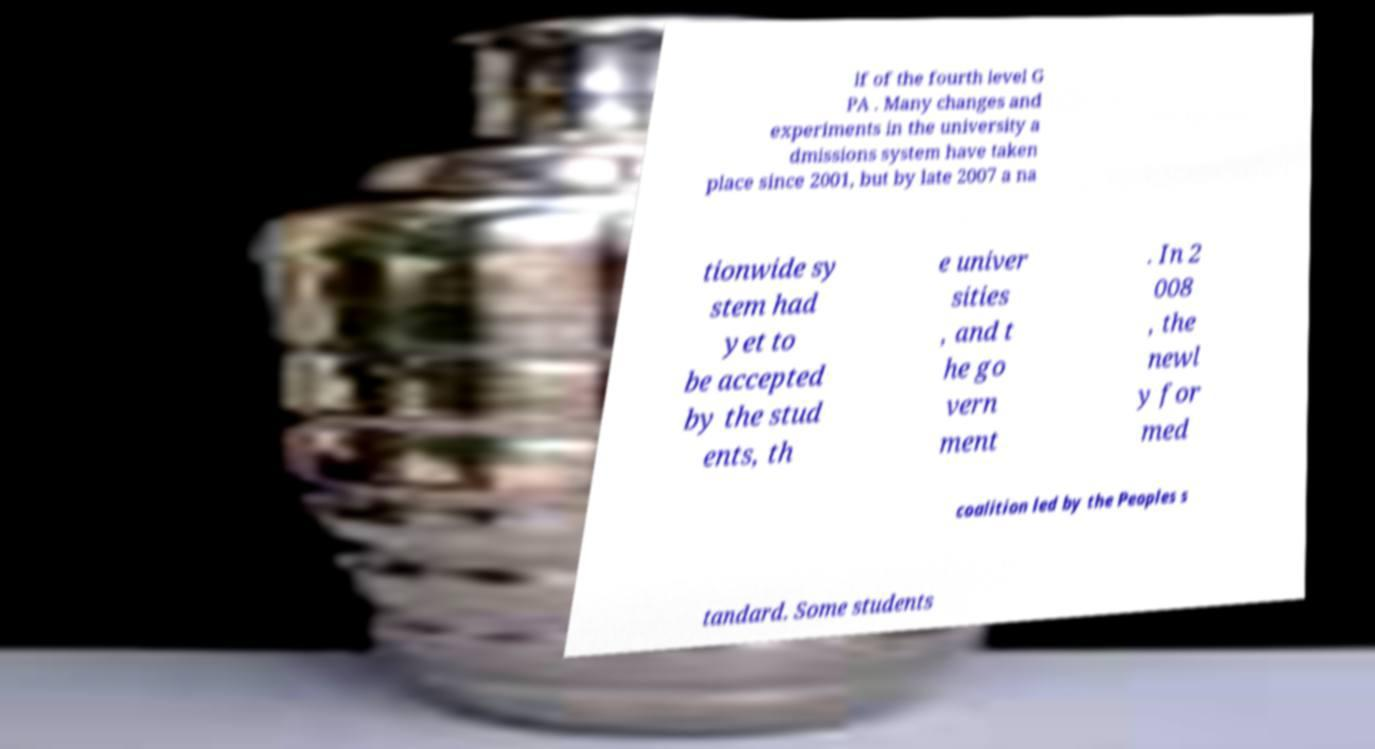What messages or text are displayed in this image? I need them in a readable, typed format. lf of the fourth level G PA . Many changes and experiments in the university a dmissions system have taken place since 2001, but by late 2007 a na tionwide sy stem had yet to be accepted by the stud ents, th e univer sities , and t he go vern ment . In 2 008 , the newl y for med coalition led by the Peoples s tandard. Some students 